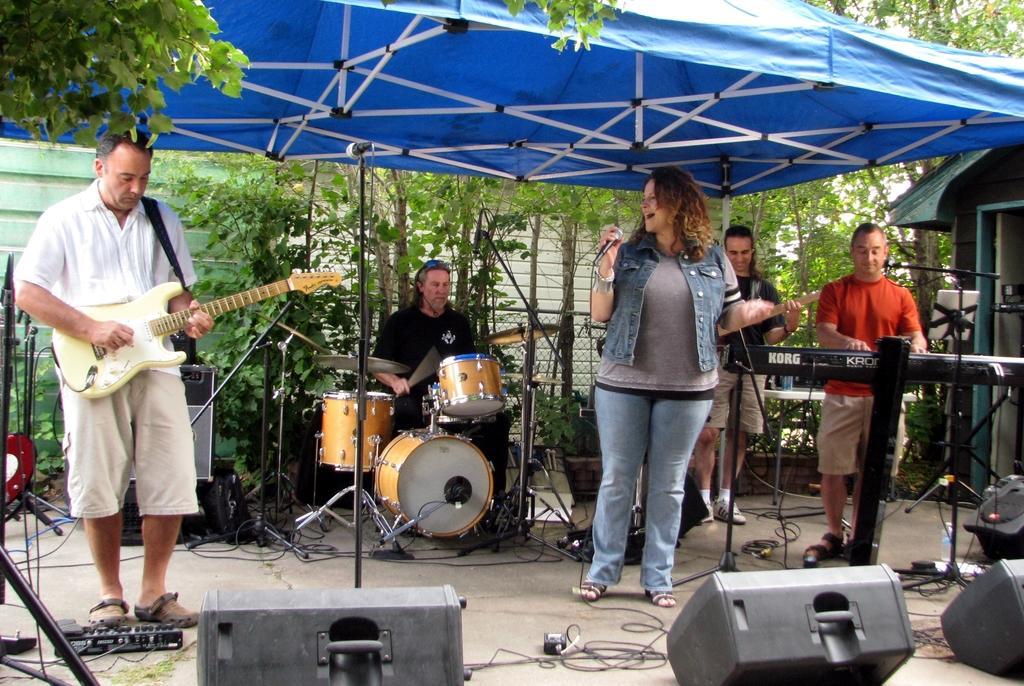Please provide a concise description of this image. this is outside a building. In the middle one lady is singing. She is holding a mic. In the left side one man is playing guitar. In the background one man is playing drum. In the right side one man is playing keyboard. another man is playing guitar behind him. They are standing under a tent. There are trees in the background and we can see a building in the background also. There are fence around the building. There are speaker attached to the instrument. 